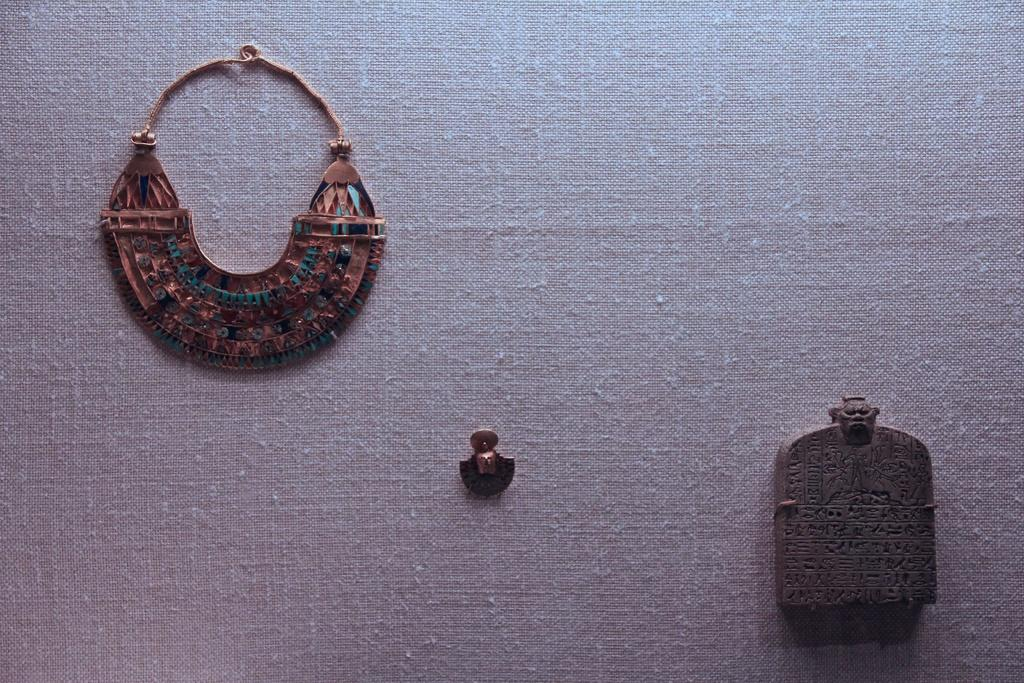What type of jewelry can be seen in the image? There is a necklace and an earring in the image. What other accessory is present in the image? There is an ornament in the image. On what surface are the items placed? The items are placed on a cloth. What type of office furniture can be seen in the image? There is no office furniture present in the image; it features jewelry and an ornament placed on a cloth. What activity is taking place in the image? The image does not depict any specific activity; it simply shows jewelry and an ornament placed on a cloth. 